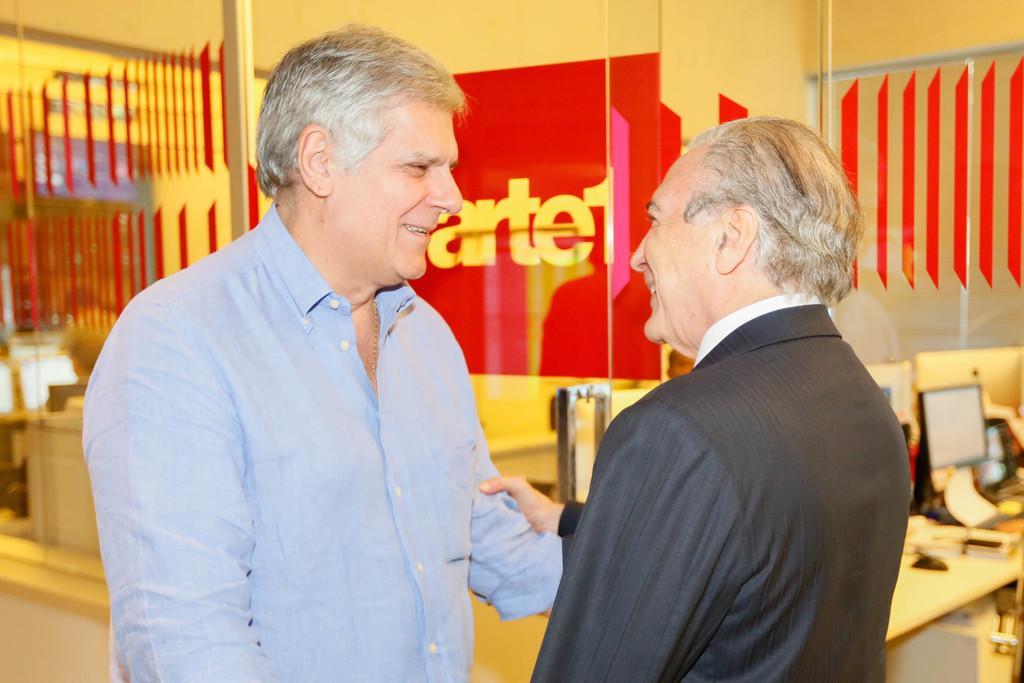In one or two sentences, can you explain what this image depicts? The picture is taken inside a room where the persons are standing, at the right corner of the picture there is a table and one system and at the left corner one person is wearing a blue shirt and behind him there is a big glass door and a wall painted in red colour. 